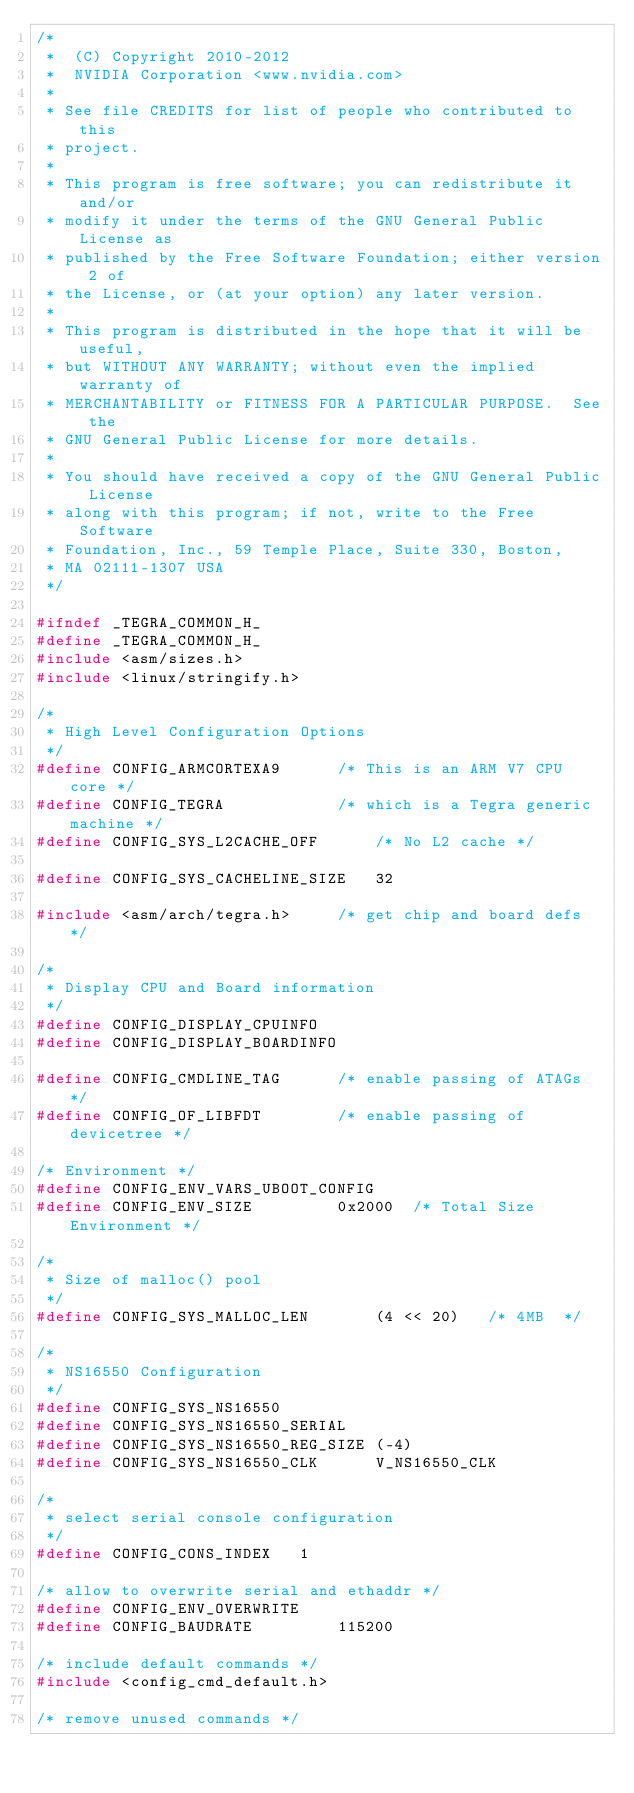<code> <loc_0><loc_0><loc_500><loc_500><_C_>/*
 *  (C) Copyright 2010-2012
 *  NVIDIA Corporation <www.nvidia.com>
 *
 * See file CREDITS for list of people who contributed to this
 * project.
 *
 * This program is free software; you can redistribute it and/or
 * modify it under the terms of the GNU General Public License as
 * published by the Free Software Foundation; either version 2 of
 * the License, or (at your option) any later version.
 *
 * This program is distributed in the hope that it will be useful,
 * but WITHOUT ANY WARRANTY; without even the implied warranty of
 * MERCHANTABILITY or FITNESS FOR A PARTICULAR PURPOSE.  See the
 * GNU General Public License for more details.
 *
 * You should have received a copy of the GNU General Public License
 * along with this program; if not, write to the Free Software
 * Foundation, Inc., 59 Temple Place, Suite 330, Boston,
 * MA 02111-1307 USA
 */

#ifndef _TEGRA_COMMON_H_
#define _TEGRA_COMMON_H_
#include <asm/sizes.h>
#include <linux/stringify.h>

/*
 * High Level Configuration Options
 */
#define CONFIG_ARMCORTEXA9		/* This is an ARM V7 CPU core */
#define CONFIG_TEGRA			/* which is a Tegra generic machine */
#define CONFIG_SYS_L2CACHE_OFF		/* No L2 cache */

#define CONFIG_SYS_CACHELINE_SIZE	32

#include <asm/arch/tegra.h>		/* get chip and board defs */

/*
 * Display CPU and Board information
 */
#define CONFIG_DISPLAY_CPUINFO
#define CONFIG_DISPLAY_BOARDINFO

#define CONFIG_CMDLINE_TAG		/* enable passing of ATAGs */
#define CONFIG_OF_LIBFDT		/* enable passing of devicetree */

/* Environment */
#define CONFIG_ENV_VARS_UBOOT_CONFIG
#define CONFIG_ENV_SIZE			0x2000	/* Total Size Environment */

/*
 * Size of malloc() pool
 */
#define CONFIG_SYS_MALLOC_LEN		(4 << 20)	/* 4MB  */

/*
 * NS16550 Configuration
 */
#define CONFIG_SYS_NS16550
#define CONFIG_SYS_NS16550_SERIAL
#define CONFIG_SYS_NS16550_REG_SIZE	(-4)
#define CONFIG_SYS_NS16550_CLK		V_NS16550_CLK

/*
 * select serial console configuration
 */
#define CONFIG_CONS_INDEX	1

/* allow to overwrite serial and ethaddr */
#define CONFIG_ENV_OVERWRITE
#define CONFIG_BAUDRATE			115200

/* include default commands */
#include <config_cmd_default.h>

/* remove unused commands */</code> 